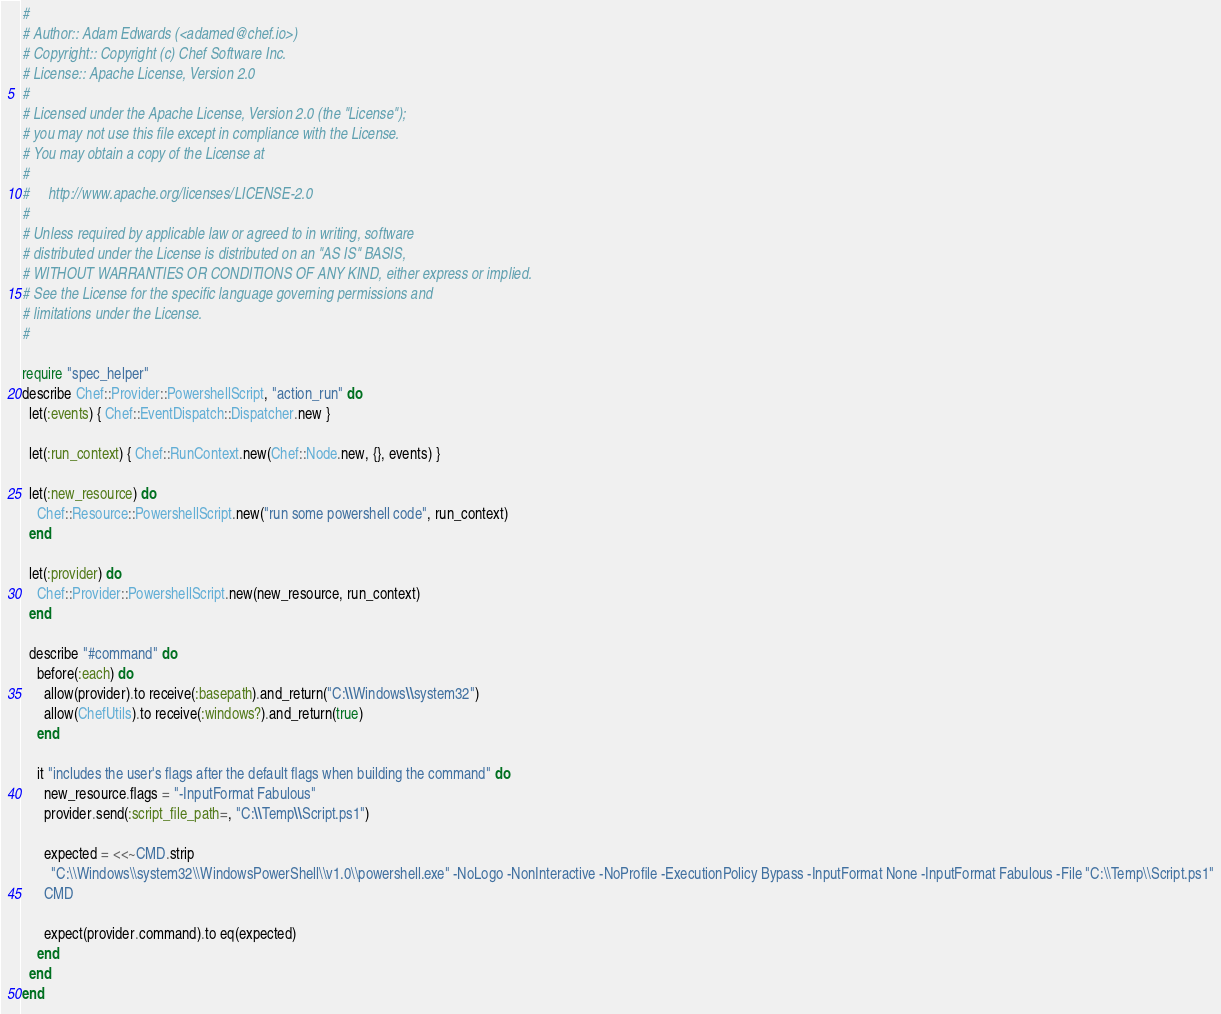<code> <loc_0><loc_0><loc_500><loc_500><_Ruby_>#
# Author:: Adam Edwards (<adamed@chef.io>)
# Copyright:: Copyright (c) Chef Software Inc.
# License:: Apache License, Version 2.0
#
# Licensed under the Apache License, Version 2.0 (the "License");
# you may not use this file except in compliance with the License.
# You may obtain a copy of the License at
#
#     http://www.apache.org/licenses/LICENSE-2.0
#
# Unless required by applicable law or agreed to in writing, software
# distributed under the License is distributed on an "AS IS" BASIS,
# WITHOUT WARRANTIES OR CONDITIONS OF ANY KIND, either express or implied.
# See the License for the specific language governing permissions and
# limitations under the License.
#

require "spec_helper"
describe Chef::Provider::PowershellScript, "action_run" do
  let(:events) { Chef::EventDispatch::Dispatcher.new }

  let(:run_context) { Chef::RunContext.new(Chef::Node.new, {}, events) }

  let(:new_resource) do
    Chef::Resource::PowershellScript.new("run some powershell code", run_context)
  end

  let(:provider) do
    Chef::Provider::PowershellScript.new(new_resource, run_context)
  end

  describe "#command" do
    before(:each) do
      allow(provider).to receive(:basepath).and_return("C:\\Windows\\system32")
      allow(ChefUtils).to receive(:windows?).and_return(true)
    end

    it "includes the user's flags after the default flags when building the command" do
      new_resource.flags = "-InputFormat Fabulous"
      provider.send(:script_file_path=, "C:\\Temp\\Script.ps1")

      expected = <<~CMD.strip
        "C:\\Windows\\system32\\WindowsPowerShell\\v1.0\\powershell.exe" -NoLogo -NonInteractive -NoProfile -ExecutionPolicy Bypass -InputFormat None -InputFormat Fabulous -File "C:\\Temp\\Script.ps1"
      CMD

      expect(provider.command).to eq(expected)
    end
  end
end
</code> 